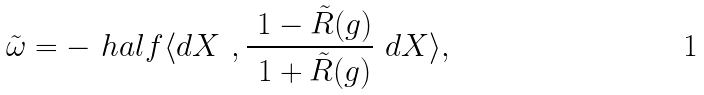<formula> <loc_0><loc_0><loc_500><loc_500>\tilde { \omega } = - \ h a l f \langle d X \ , \frac { \ 1 - \tilde { R } ( g ) } { \ 1 + \tilde { R } ( g ) } \ d X \rangle ,</formula> 